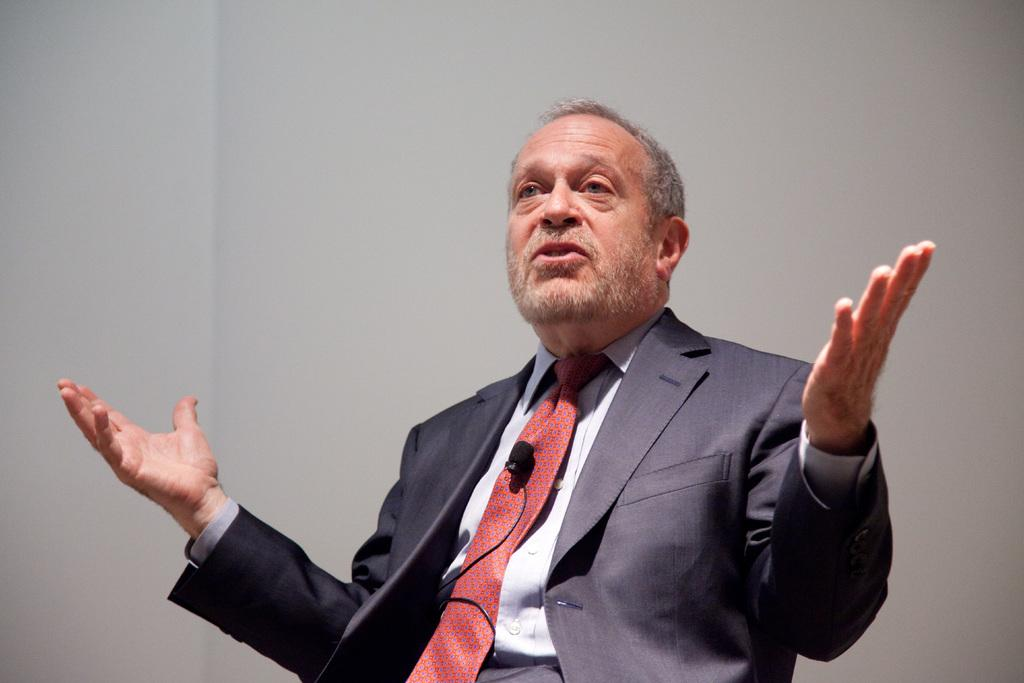Who is present in the image? There is a man in the image. What is the man wearing in the image? The man is wearing a microphone in the image. What can be seen behind the man in the image? There is a wall visible in the image. What type of linen is being used to cover the government building in the image? There is no linen or government building present in the image. 